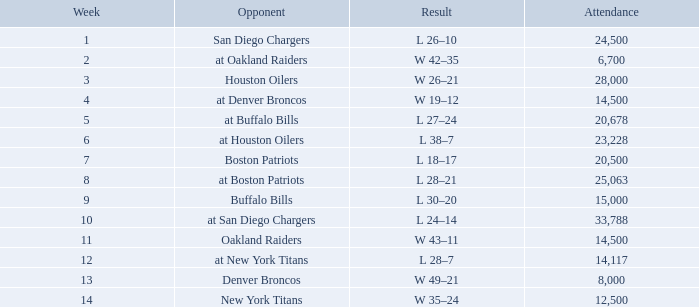What is the low attendance rate against buffalo bills? 15000.0. 